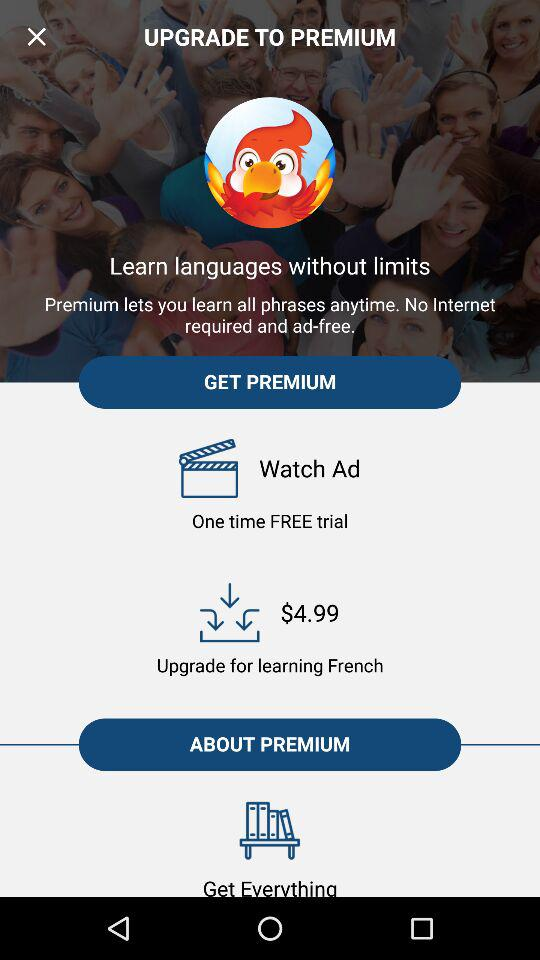What's the number of free trial? The free trial is available only once. 